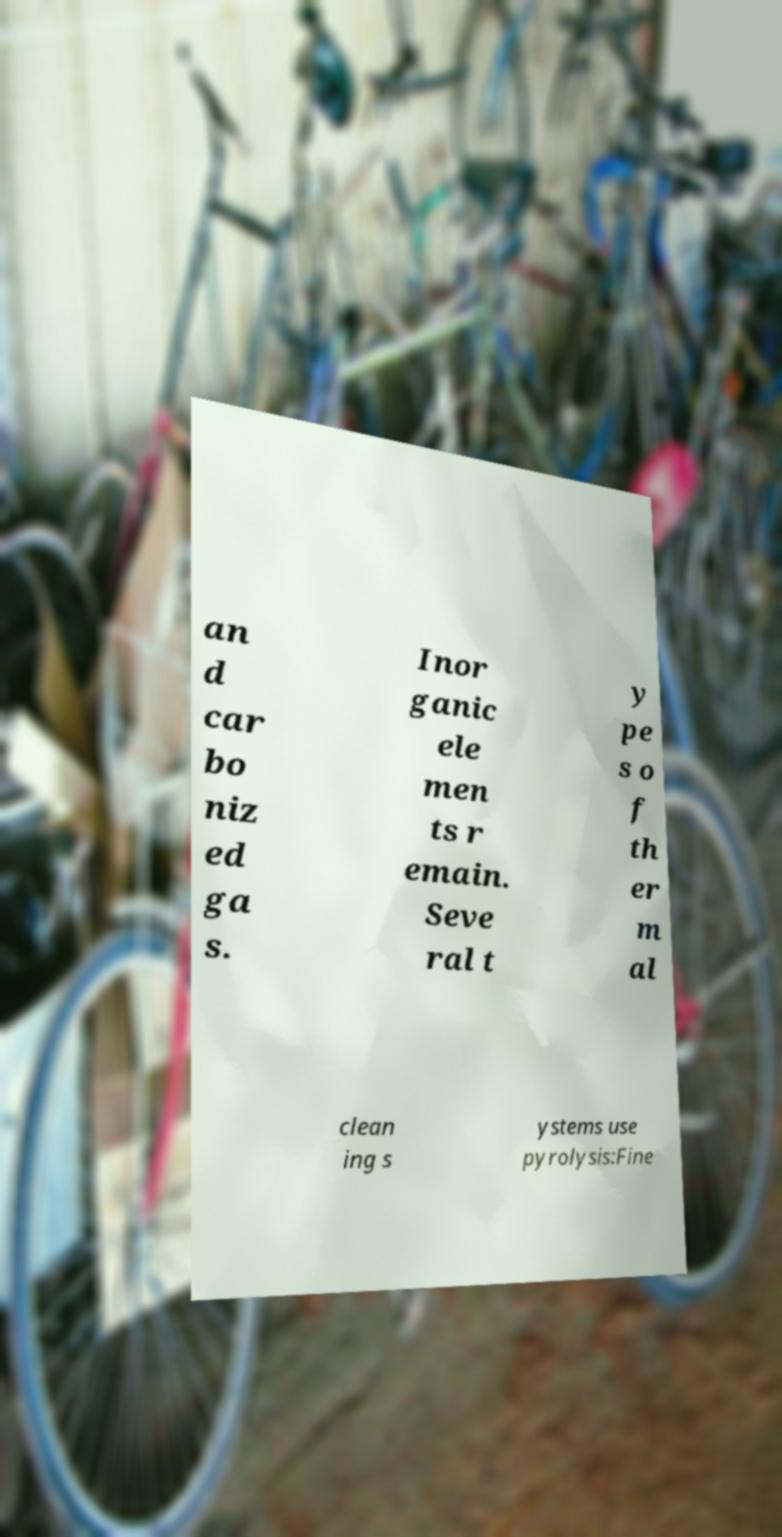There's text embedded in this image that I need extracted. Can you transcribe it verbatim? an d car bo niz ed ga s. Inor ganic ele men ts r emain. Seve ral t y pe s o f th er m al clean ing s ystems use pyrolysis:Fine 